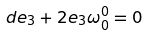Convert formula to latex. <formula><loc_0><loc_0><loc_500><loc_500>d e _ { 3 } + 2 e _ { 3 } \omega ^ { 0 } _ { 0 } = 0</formula> 